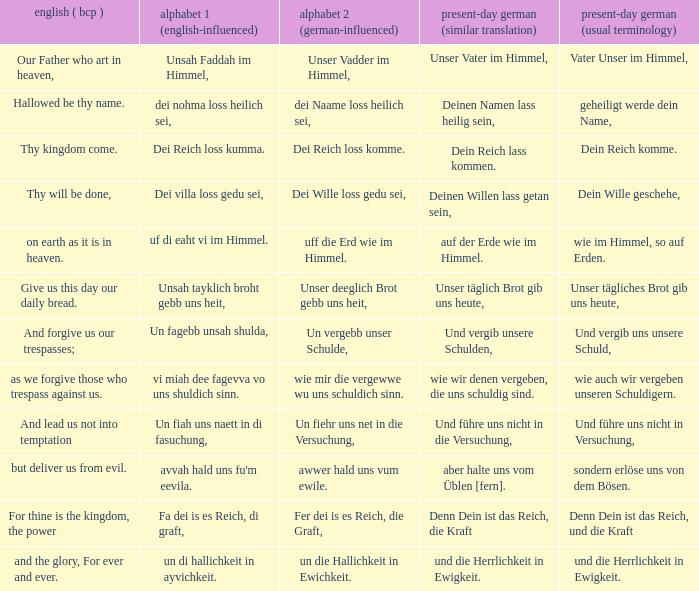What is the modern german standard wording for the german based writing system 2 phrase "wie mir die vergewwe wu uns schuldich sinn."? Wie auch wir vergeben unseren schuldigern. 